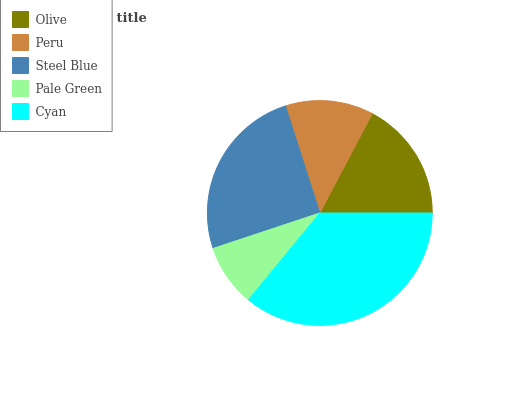Is Pale Green the minimum?
Answer yes or no. Yes. Is Cyan the maximum?
Answer yes or no. Yes. Is Peru the minimum?
Answer yes or no. No. Is Peru the maximum?
Answer yes or no. No. Is Olive greater than Peru?
Answer yes or no. Yes. Is Peru less than Olive?
Answer yes or no. Yes. Is Peru greater than Olive?
Answer yes or no. No. Is Olive less than Peru?
Answer yes or no. No. Is Olive the high median?
Answer yes or no. Yes. Is Olive the low median?
Answer yes or no. Yes. Is Steel Blue the high median?
Answer yes or no. No. Is Cyan the low median?
Answer yes or no. No. 